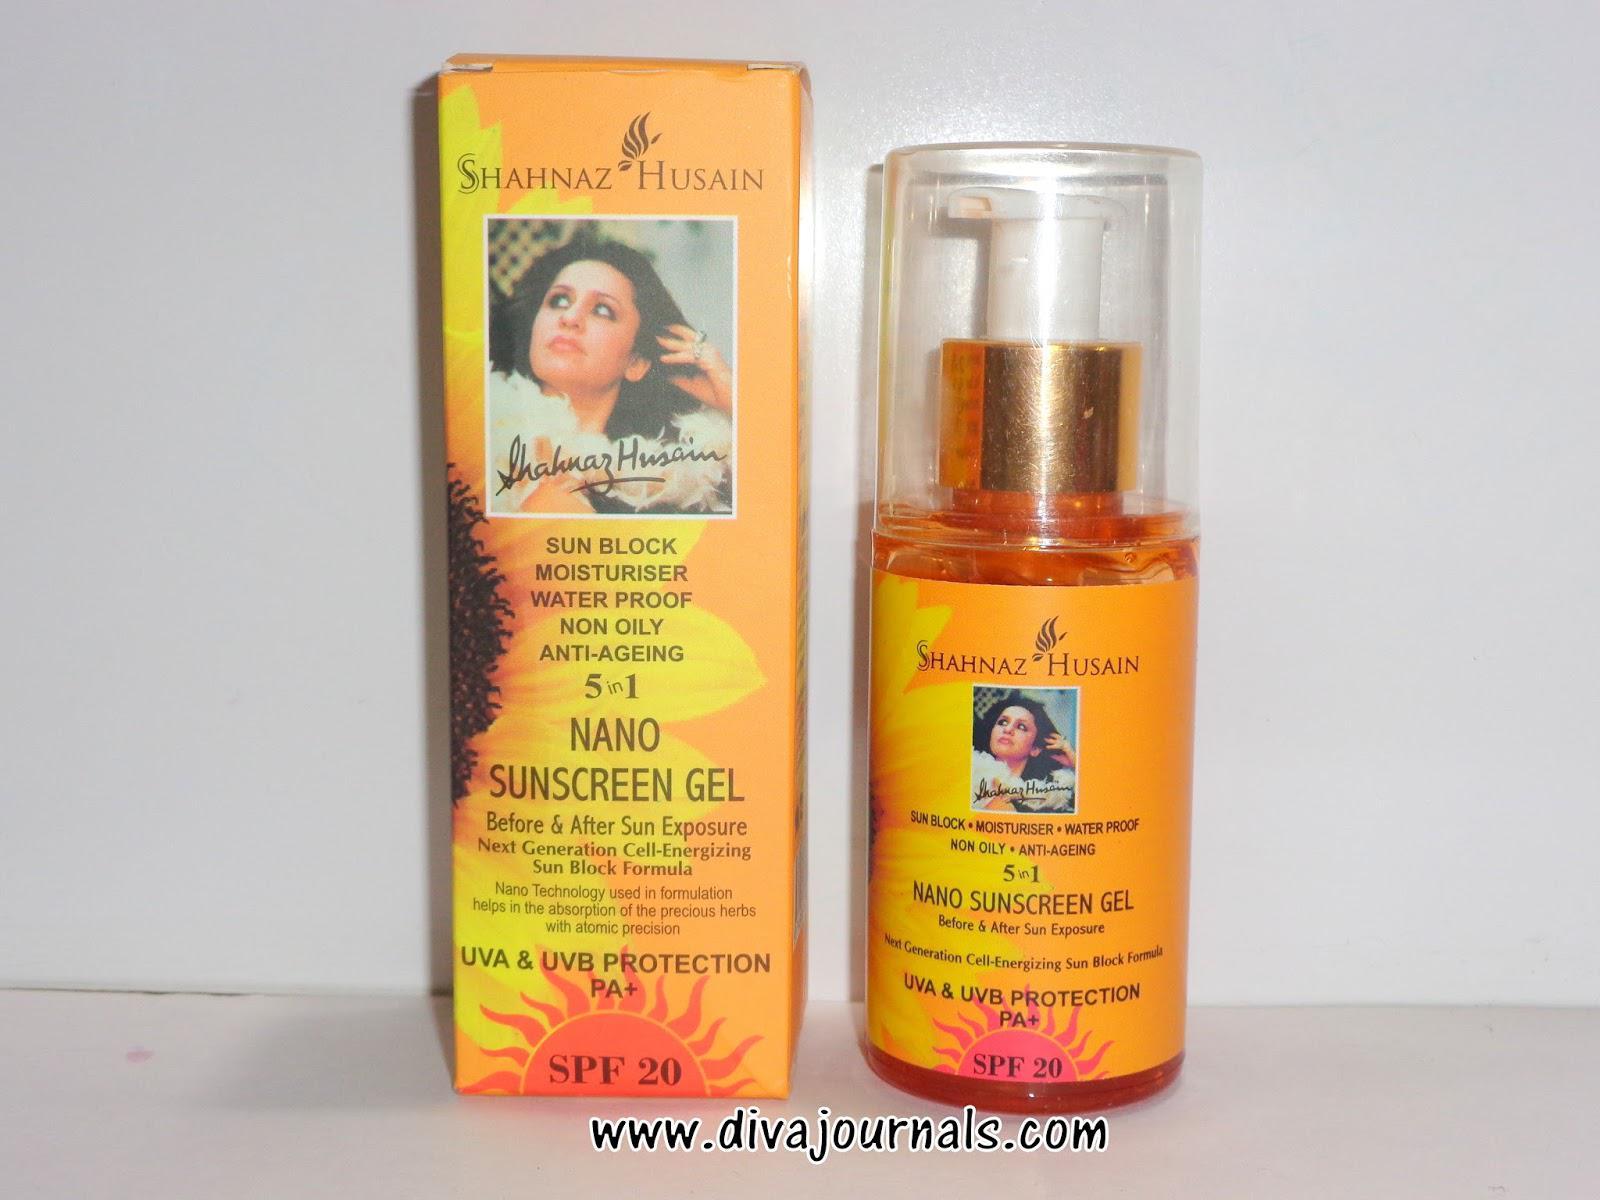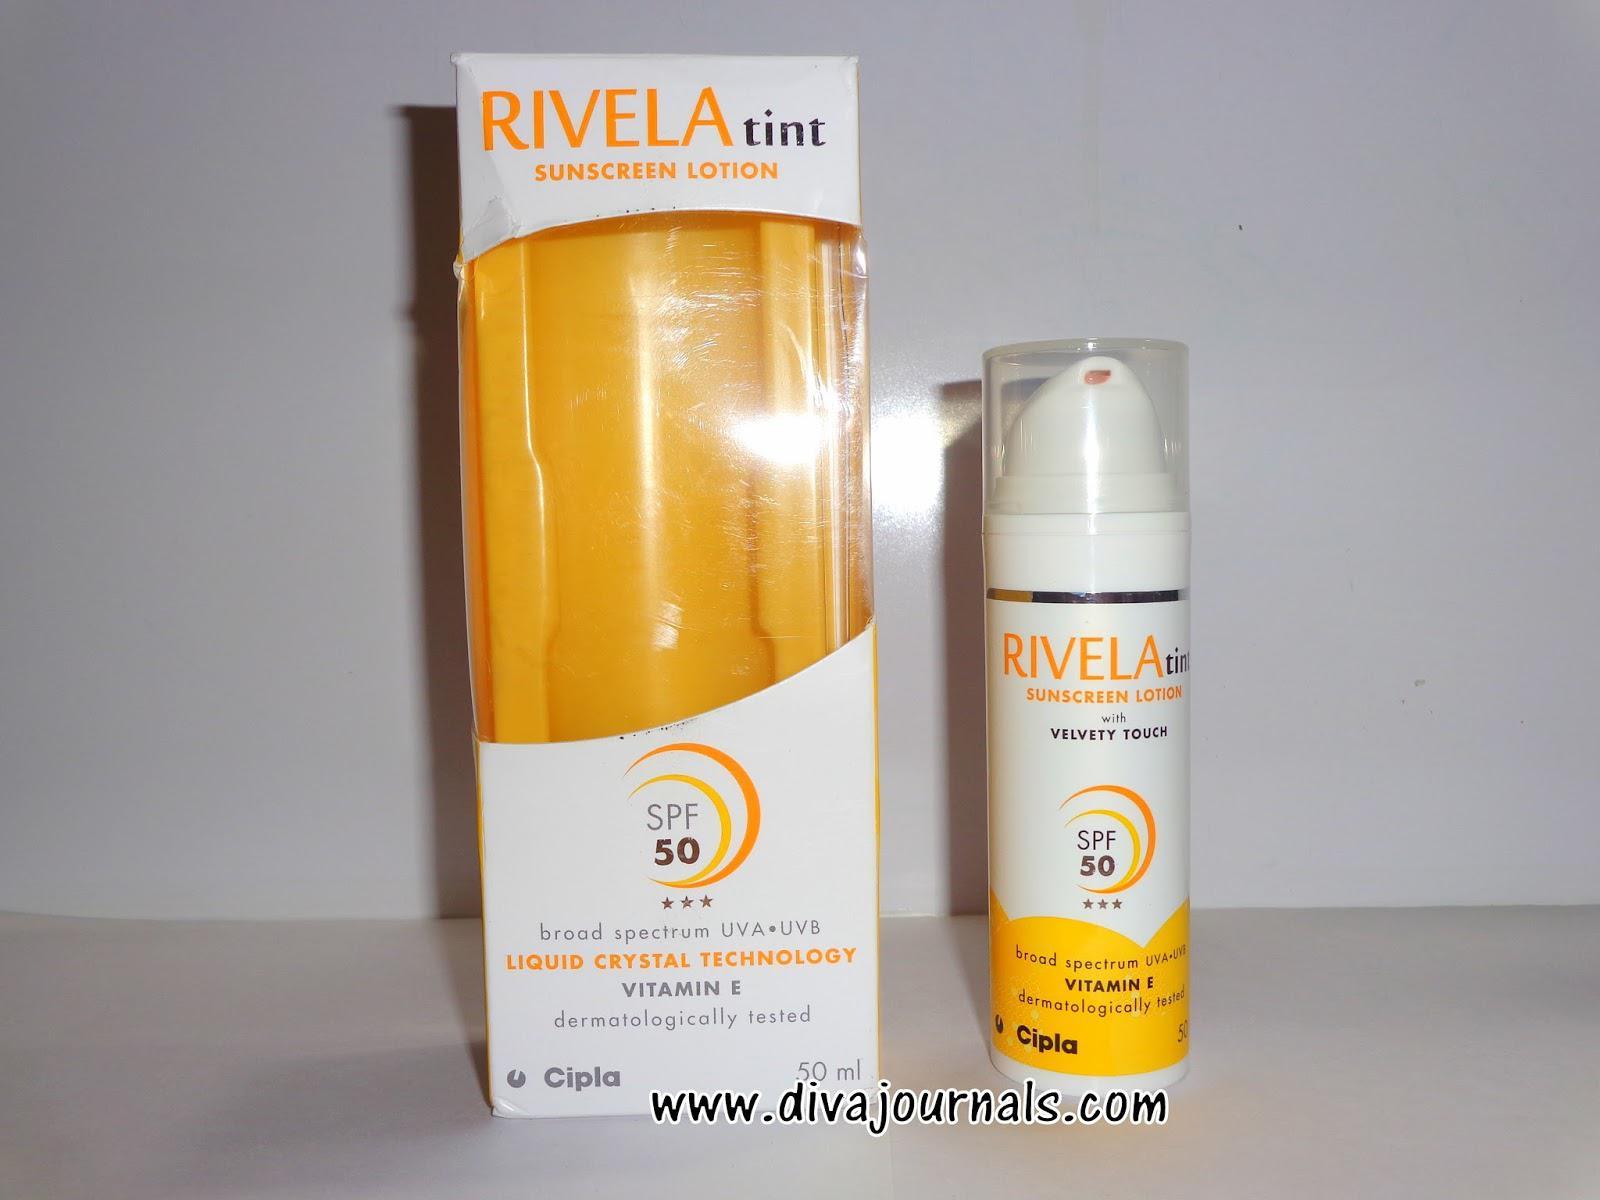The first image is the image on the left, the second image is the image on the right. Examine the images to the left and right. Is the description "Each image shows one skincare product next to its box." accurate? Answer yes or no. Yes. The first image is the image on the left, the second image is the image on the right. Assess this claim about the two images: "Each image shows one sunscreen product standing to the right of the box the product is packaged in to be sold.". Correct or not? Answer yes or no. Yes. 